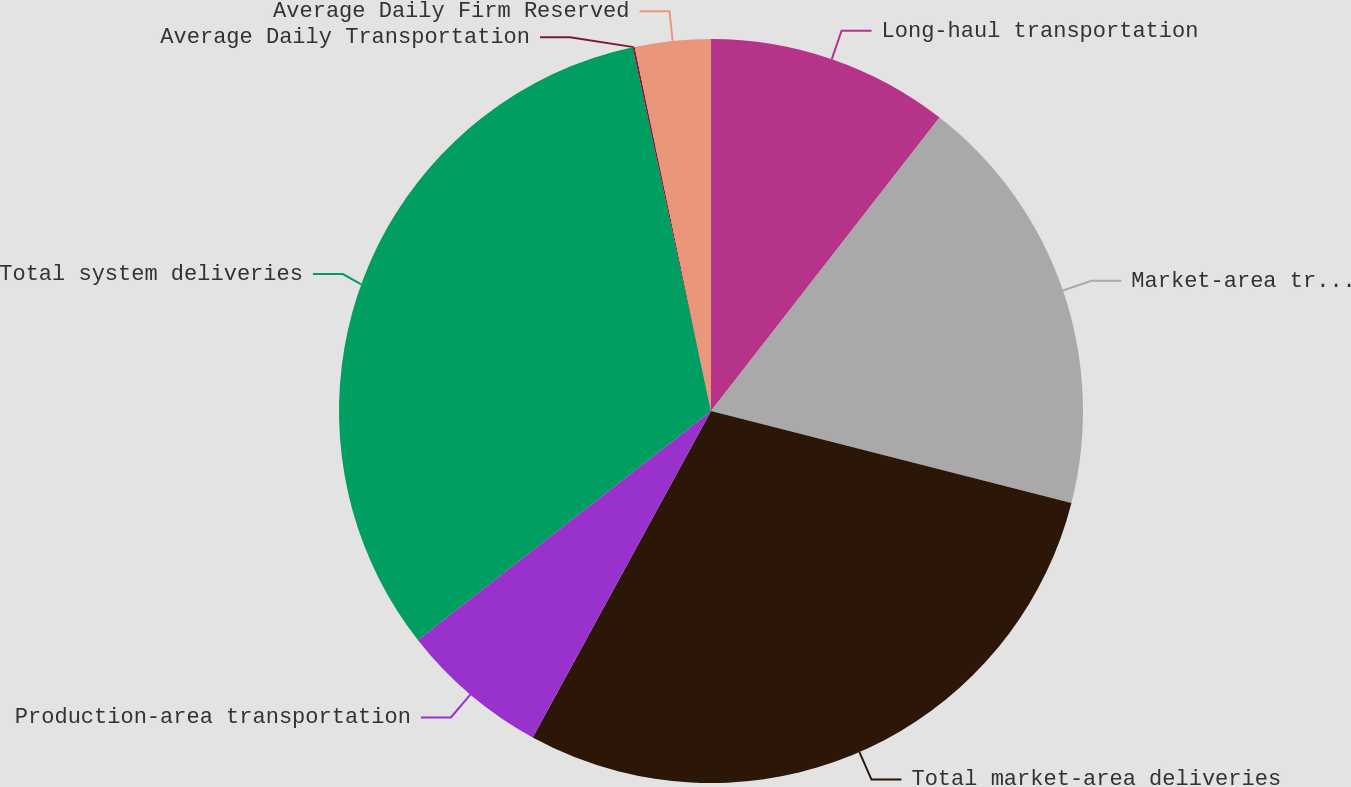Convert chart to OTSL. <chart><loc_0><loc_0><loc_500><loc_500><pie_chart><fcel>Long-haul transportation<fcel>Market-area transportation<fcel>Total market-area deliveries<fcel>Production-area transportation<fcel>Total system deliveries<fcel>Average Daily Transportation<fcel>Average Daily Firm Reserved<nl><fcel>10.53%<fcel>18.45%<fcel>28.98%<fcel>6.49%<fcel>32.18%<fcel>0.09%<fcel>3.29%<nl></chart> 